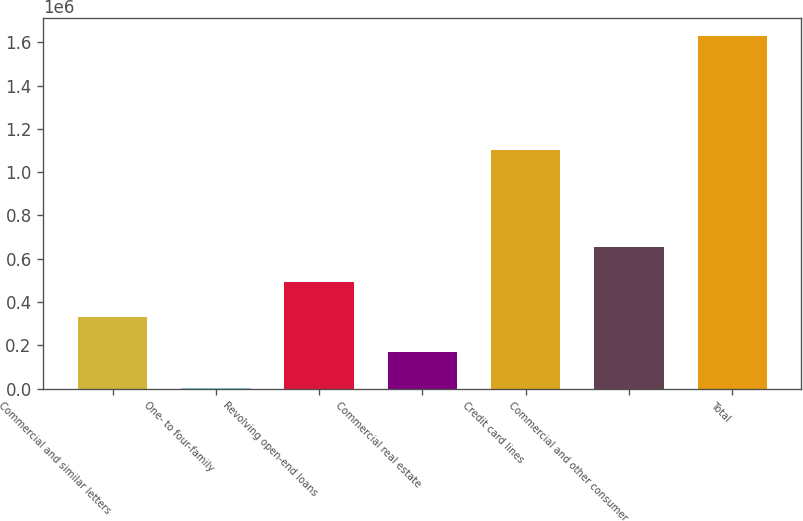<chart> <loc_0><loc_0><loc_500><loc_500><bar_chart><fcel>Commercial and similar letters<fcel>One- to four-family<fcel>Revolving open-end loans<fcel>Commercial real estate<fcel>Credit card lines<fcel>Commercial and other consumer<fcel>Total<nl><fcel>329859<fcel>4587<fcel>492496<fcel>167223<fcel>1.10354e+06<fcel>655132<fcel>1.63095e+06<nl></chart> 